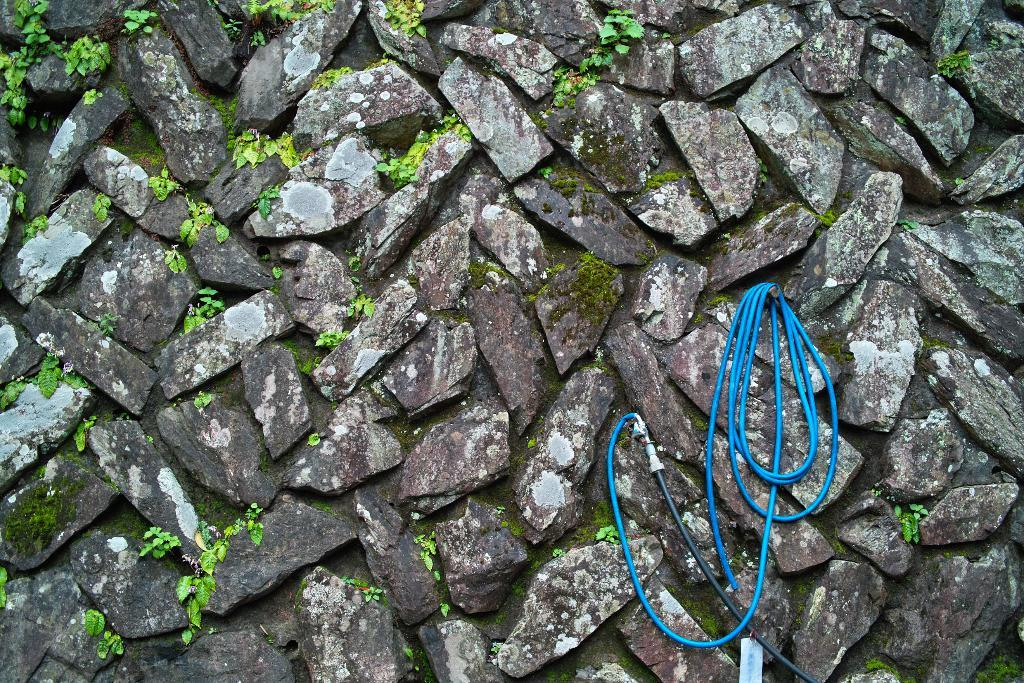What color is the water pipe in the image? The water pipe in the image is blue. How is the water pipe positioned in the image? The water pipe is hanged on a nail. What type of vegetation can be seen on a wall in the image? There is grass visible on a wall in the image. What type of statement is being made by the orange in the image? There is no orange present in the image, so no statement can be made by it. 